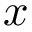<formula> <loc_0><loc_0><loc_500><loc_500>x</formula> 